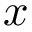<formula> <loc_0><loc_0><loc_500><loc_500>x</formula> 